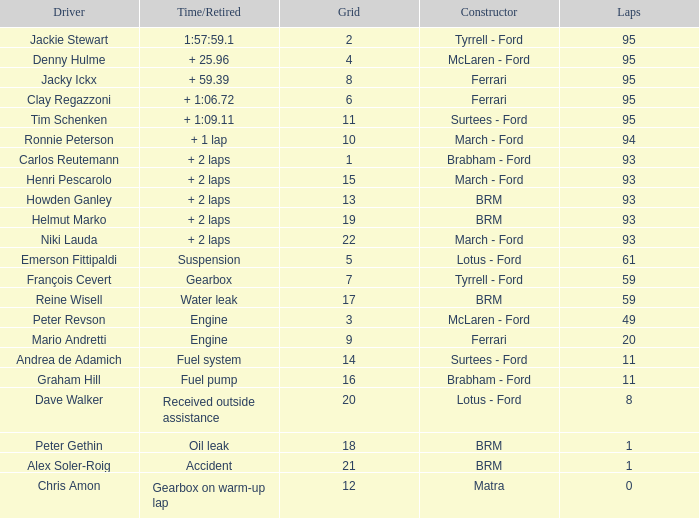How many grids does dave walker have? 1.0. 